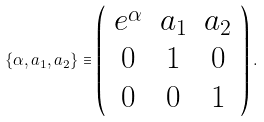<formula> <loc_0><loc_0><loc_500><loc_500>\left \{ \alpha , a _ { 1 } , a _ { 2 } \right \} \equiv \left ( \begin{array} { c c c } e ^ { \alpha } & a _ { 1 } & a _ { 2 } \\ 0 & 1 & 0 \\ 0 & 0 & 1 \end{array} \right ) .</formula> 